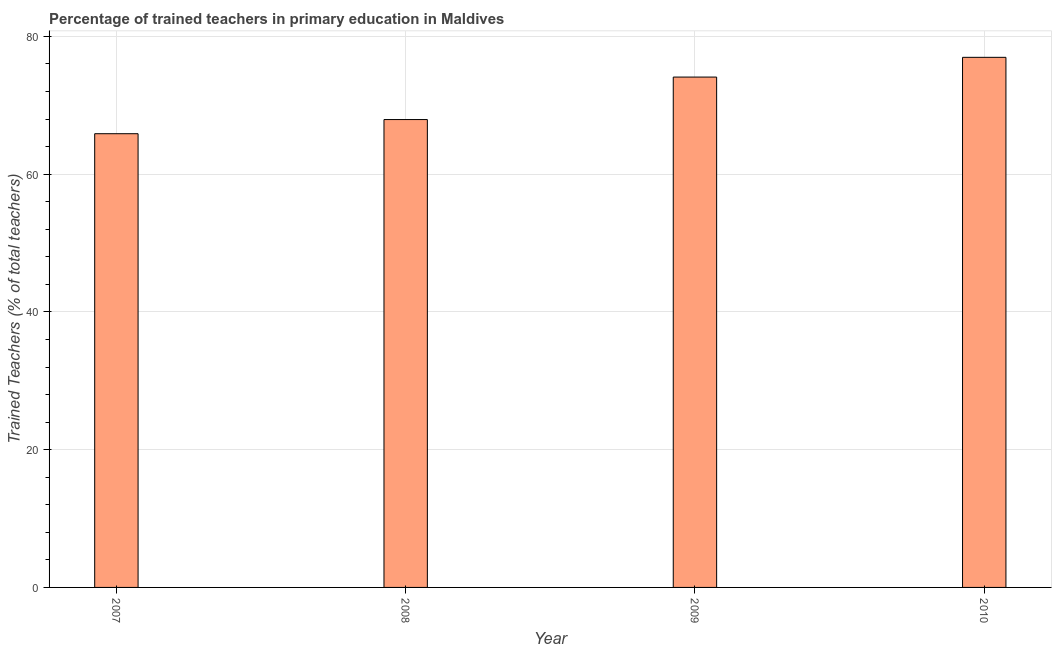Does the graph contain any zero values?
Ensure brevity in your answer.  No. What is the title of the graph?
Give a very brief answer. Percentage of trained teachers in primary education in Maldives. What is the label or title of the Y-axis?
Make the answer very short. Trained Teachers (% of total teachers). What is the percentage of trained teachers in 2010?
Your answer should be compact. 76.96. Across all years, what is the maximum percentage of trained teachers?
Your answer should be very brief. 76.96. Across all years, what is the minimum percentage of trained teachers?
Offer a very short reply. 65.87. In which year was the percentage of trained teachers maximum?
Give a very brief answer. 2010. In which year was the percentage of trained teachers minimum?
Your answer should be compact. 2007. What is the sum of the percentage of trained teachers?
Give a very brief answer. 284.84. What is the difference between the percentage of trained teachers in 2008 and 2009?
Keep it short and to the point. -6.17. What is the average percentage of trained teachers per year?
Make the answer very short. 71.21. What is the median percentage of trained teachers?
Your answer should be compact. 71.01. In how many years, is the percentage of trained teachers greater than 8 %?
Make the answer very short. 4. What is the ratio of the percentage of trained teachers in 2007 to that in 2008?
Give a very brief answer. 0.97. Is the difference between the percentage of trained teachers in 2009 and 2010 greater than the difference between any two years?
Your answer should be compact. No. What is the difference between the highest and the second highest percentage of trained teachers?
Your answer should be compact. 2.87. Is the sum of the percentage of trained teachers in 2007 and 2010 greater than the maximum percentage of trained teachers across all years?
Your answer should be compact. Yes. What is the difference between the highest and the lowest percentage of trained teachers?
Your response must be concise. 11.09. In how many years, is the percentage of trained teachers greater than the average percentage of trained teachers taken over all years?
Offer a very short reply. 2. How many bars are there?
Provide a short and direct response. 4. Are all the bars in the graph horizontal?
Your answer should be very brief. No. How many years are there in the graph?
Offer a very short reply. 4. What is the Trained Teachers (% of total teachers) of 2007?
Your answer should be compact. 65.87. What is the Trained Teachers (% of total teachers) in 2008?
Ensure brevity in your answer.  67.92. What is the Trained Teachers (% of total teachers) in 2009?
Provide a short and direct response. 74.09. What is the Trained Teachers (% of total teachers) in 2010?
Offer a terse response. 76.96. What is the difference between the Trained Teachers (% of total teachers) in 2007 and 2008?
Offer a terse response. -2.06. What is the difference between the Trained Teachers (% of total teachers) in 2007 and 2009?
Your answer should be compact. -8.22. What is the difference between the Trained Teachers (% of total teachers) in 2007 and 2010?
Ensure brevity in your answer.  -11.09. What is the difference between the Trained Teachers (% of total teachers) in 2008 and 2009?
Your response must be concise. -6.17. What is the difference between the Trained Teachers (% of total teachers) in 2008 and 2010?
Make the answer very short. -9.03. What is the difference between the Trained Teachers (% of total teachers) in 2009 and 2010?
Your answer should be very brief. -2.87. What is the ratio of the Trained Teachers (% of total teachers) in 2007 to that in 2008?
Your answer should be compact. 0.97. What is the ratio of the Trained Teachers (% of total teachers) in 2007 to that in 2009?
Your answer should be compact. 0.89. What is the ratio of the Trained Teachers (% of total teachers) in 2007 to that in 2010?
Offer a very short reply. 0.86. What is the ratio of the Trained Teachers (% of total teachers) in 2008 to that in 2009?
Make the answer very short. 0.92. What is the ratio of the Trained Teachers (% of total teachers) in 2008 to that in 2010?
Offer a terse response. 0.88. What is the ratio of the Trained Teachers (% of total teachers) in 2009 to that in 2010?
Your answer should be very brief. 0.96. 